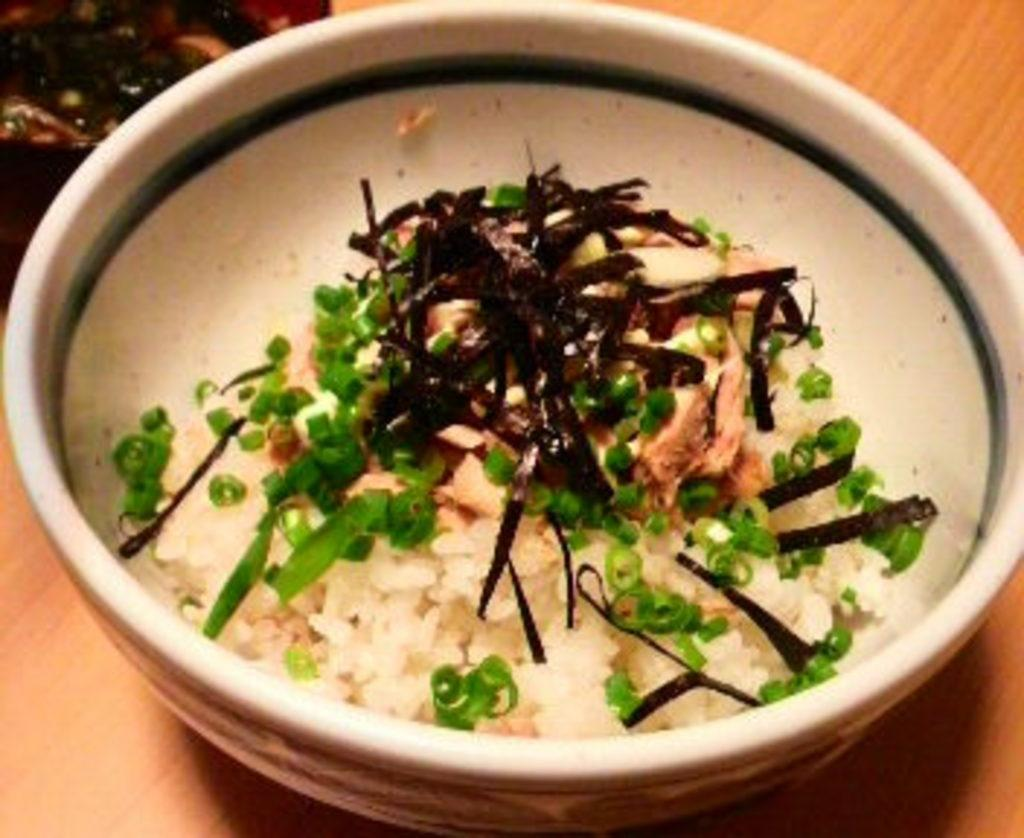What is on the table in the image? There is a bowl on the table in the image. What is inside the bowl? The bowl contains rice. Is there anything else on the rice besides the rice itself? Yes, there is garnish on the rice. What type of dinosaur can be seen in the image? There are no dinosaurs present in the image. What is the bucket used for in the image? There is no bucket present in the image. 